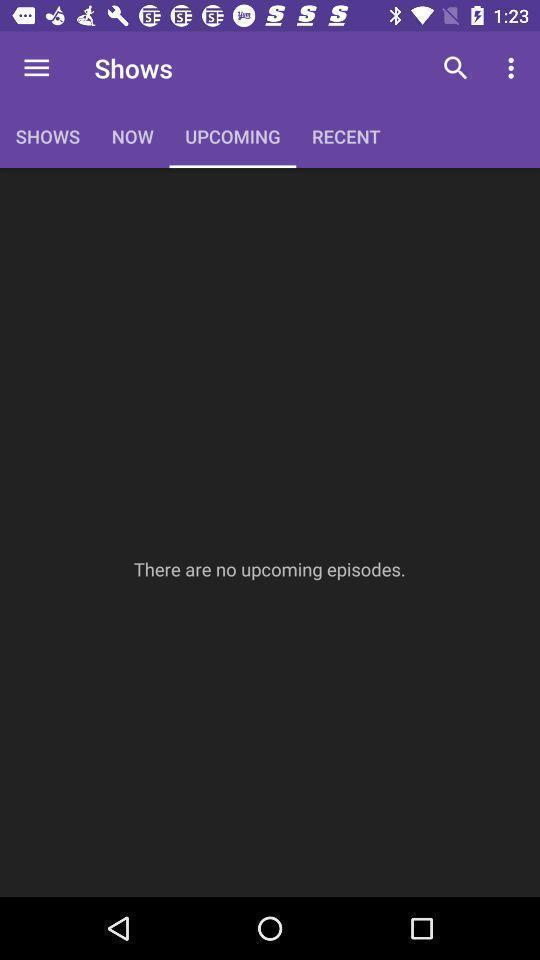What is the overall content of this screenshot? Page showing different categories in app. 